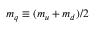<formula> <loc_0><loc_0><loc_500><loc_500>m _ { q } \equiv ( m _ { u } + m _ { d } ) / 2</formula> 